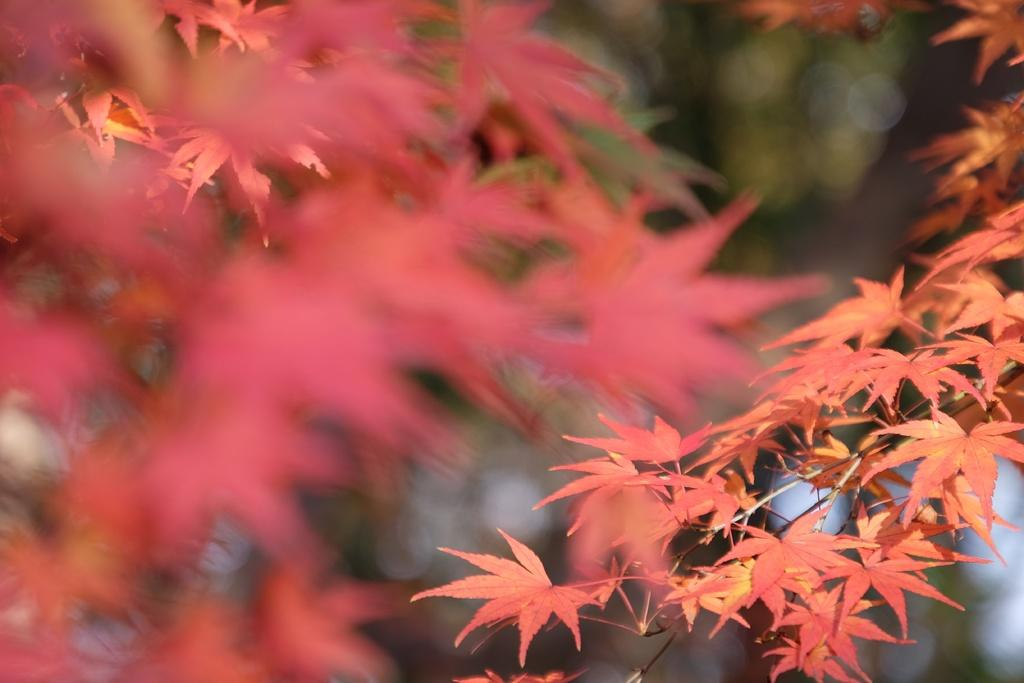What is located in the front of the image? There are leaves in the front of the image. Can you describe the background of the image? The background of the image is blurry. How many sisters are present in the image? There is no mention of a sister or any people in the image; it only features leaves and a blurry background. 